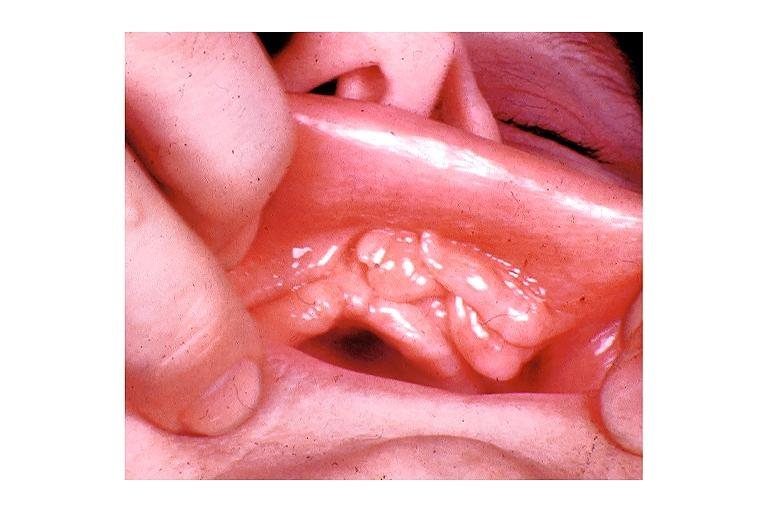what does this image show?
Answer the question using a single word or phrase. Epulis fissuratum 